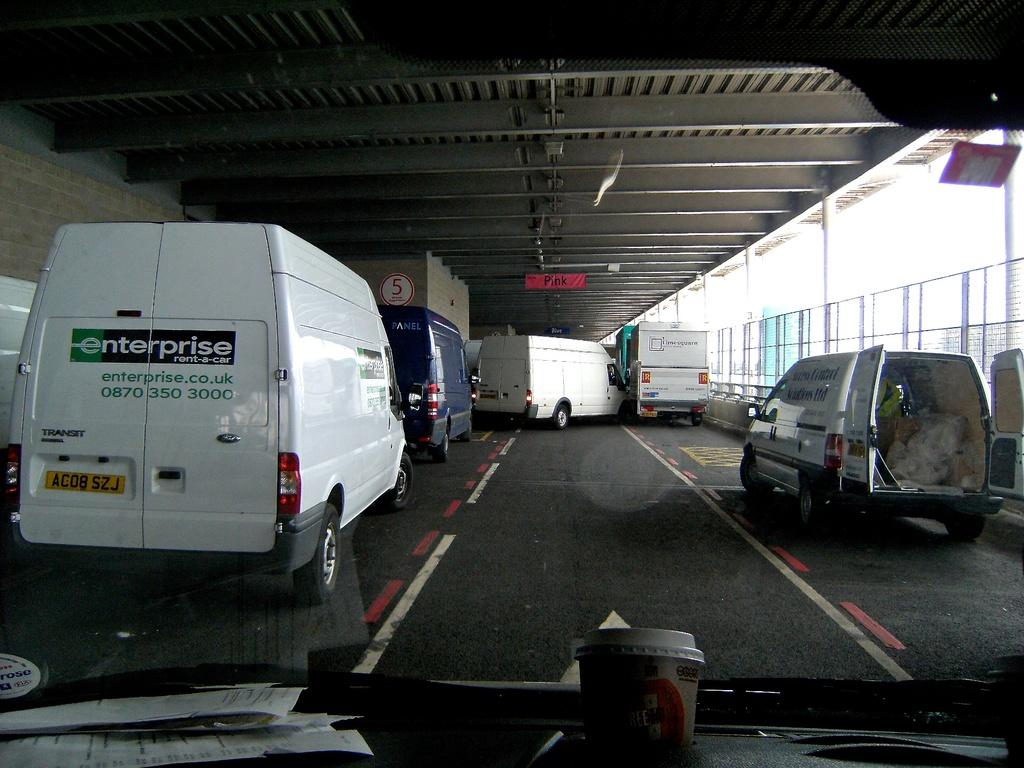What can be seen in the image? There are vehicles in the image. What is inside the vehicle? There are papers and a cup in the vehicle. What is located on the left side of the image? There are poles and railings on the left side of the image. What is near the ceiling in the image? There is a board near the ceiling in the image. How does the flock of birds contribute to the image? There are no birds, flock or otherwise, present in the image. 